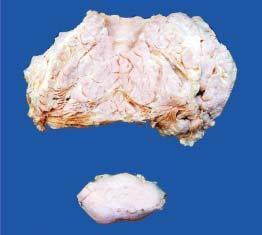does the masses show circumscribed?
Answer the question using a single word or phrase. No 